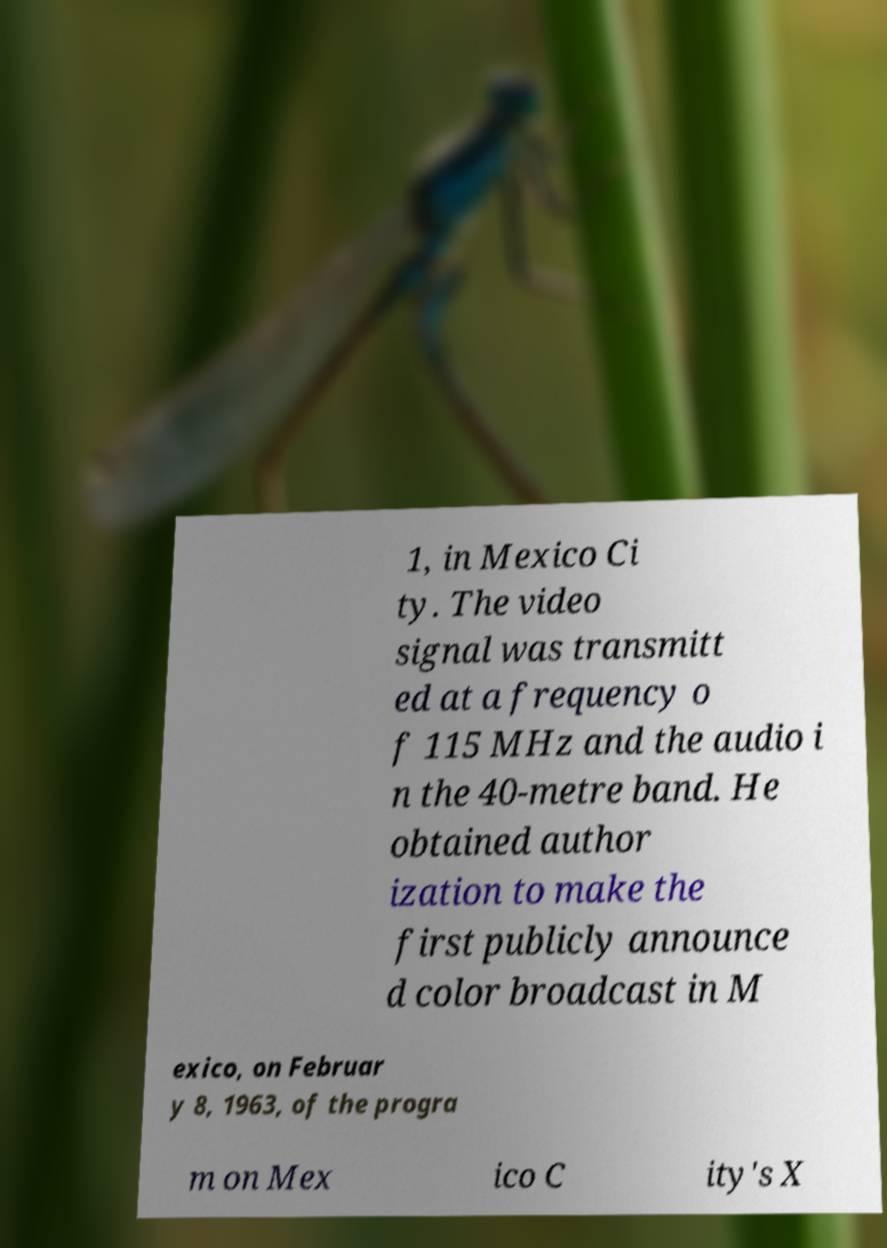Could you extract and type out the text from this image? 1, in Mexico Ci ty. The video signal was transmitt ed at a frequency o f 115 MHz and the audio i n the 40-metre band. He obtained author ization to make the first publicly announce d color broadcast in M exico, on Februar y 8, 1963, of the progra m on Mex ico C ity's X 